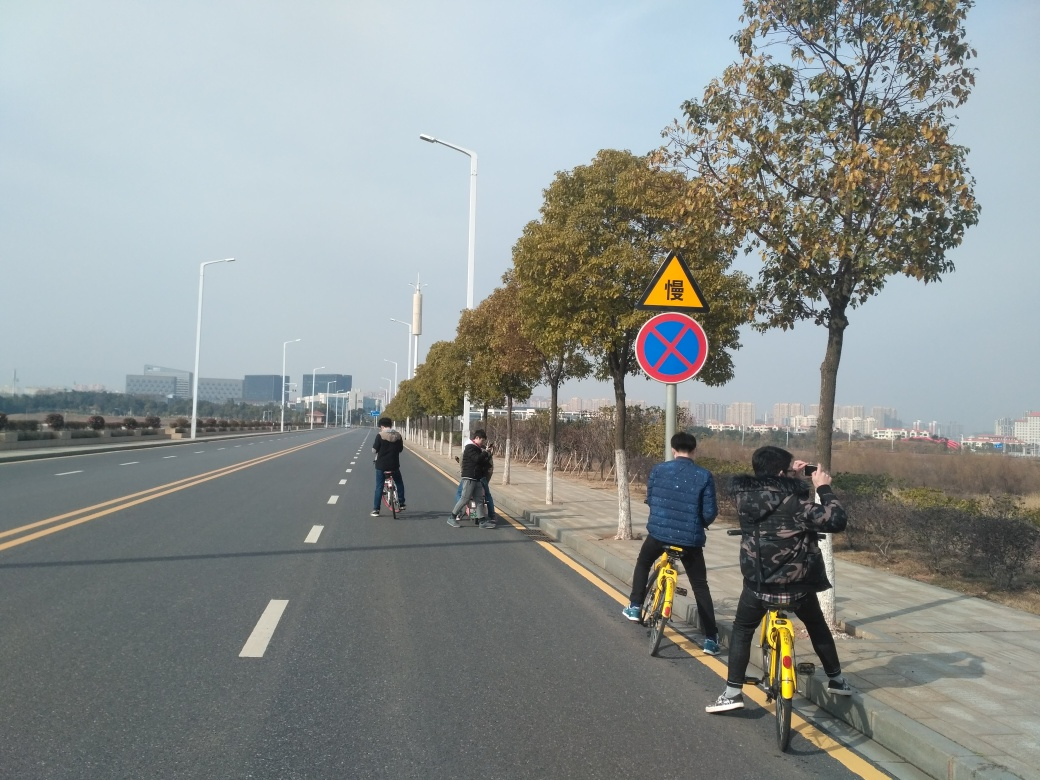Can you tell me what road sign is visible and what does it signify? Certainly! In the image, there’s a road sign with a blue circle and a red border with a red slash through it. This sign generally indicates that stopping or parking is not allowed in that area. It aims to ensure that traffic flows smoothly without obstructions. 